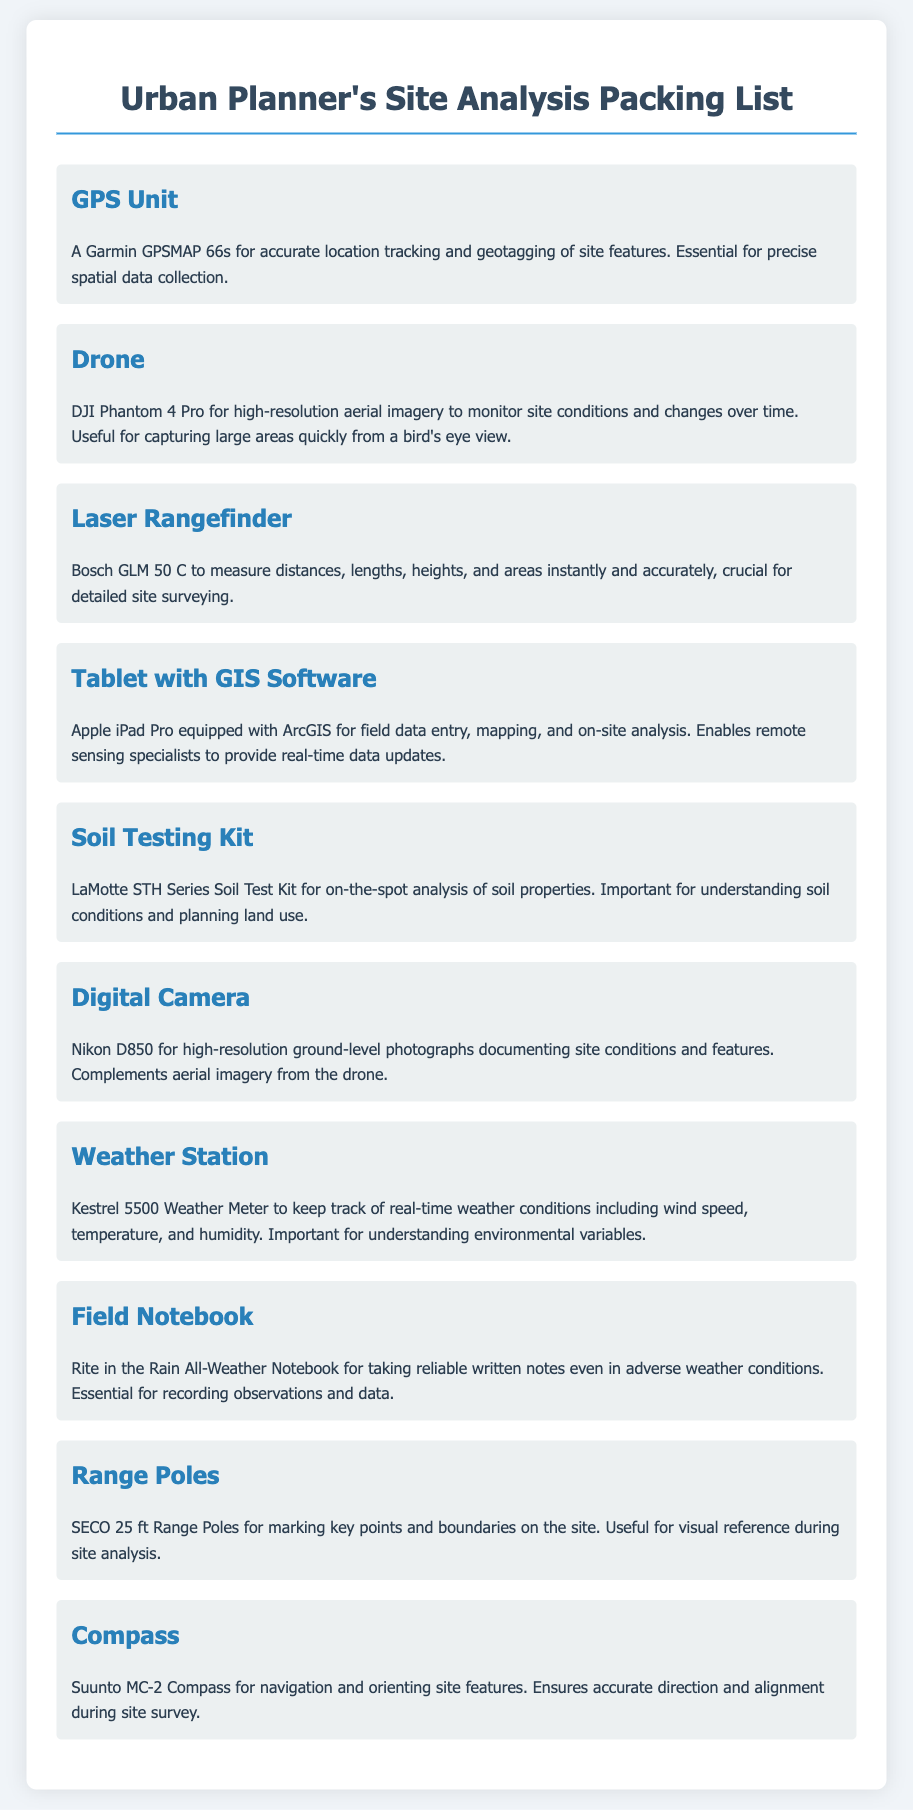What is the purpose of the GPS Unit? The GPS Unit is for accurate location tracking and geotagging of site features, essential for precise spatial data collection.
Answer: Accurate location tracking What is the model of the Drone listed? The document specifies the drone model as DJI Phantom 4 Pro for high-resolution aerial imagery.
Answer: DJI Phantom 4 Pro What key feature does the Laser Rangefinder provide? The Laser Rangefinder measures distances, lengths, heights, and areas instantly and accurately, crucial for detailed site surveying.
Answer: Detailed site surveying Which tablet is mentioned for GIS software? The Apple iPad Pro is mentioned as the tablet equipped with ArcGIS for field data entry and mapping.
Answer: Apple iPad Pro What does the Soil Testing Kit analyze? The Soil Testing Kit analyzes soil properties for understanding soil conditions and planning land use.
Answer: Soil properties Why is a Digital Camera included in the packing list? The Digital Camera documents site conditions and features with high-resolution photographs, complementing aerial imagery.
Answer: Documenting site conditions What weather conditions can the Weather Station track? The Weather Station tracks wind speed, temperature, and humidity, important for understanding environmental variables.
Answer: Wind speed, temperature, humidity What purpose do Range Poles serve? Range Poles are used for marking key points and boundaries on the site for visual reference during site analysis.
Answer: Marking key points Which compass model is listed in the document? The listed compass model is Suunto MC-2 for navigation and orienting site features.
Answer: Suunto MC-2 What type of notebook is recommended for adverse weather? The document recommends a Rite in the Rain All-Weather Notebook for taking reliable written notes in adverse weather.
Answer: Rite in the Rain All-Weather Notebook 